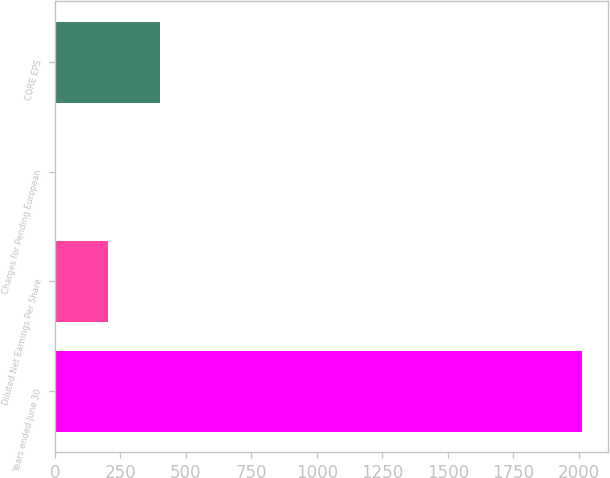Convert chart. <chart><loc_0><loc_0><loc_500><loc_500><bar_chart><fcel>Years ended June 30<fcel>Diluted Net Earnings Per Share<fcel>Charges for Pending European<fcel>CORE EPS<nl><fcel>2012<fcel>201.23<fcel>0.03<fcel>402.43<nl></chart> 